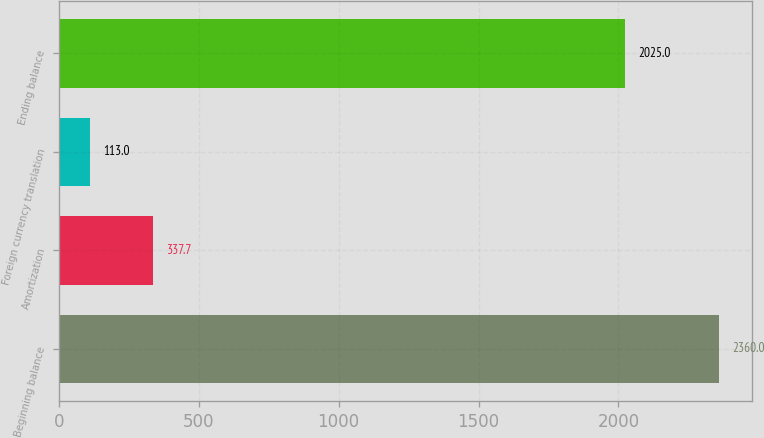Convert chart. <chart><loc_0><loc_0><loc_500><loc_500><bar_chart><fcel>Beginning balance<fcel>Amortization<fcel>Foreign currency translation<fcel>Ending balance<nl><fcel>2360<fcel>337.7<fcel>113<fcel>2025<nl></chart> 